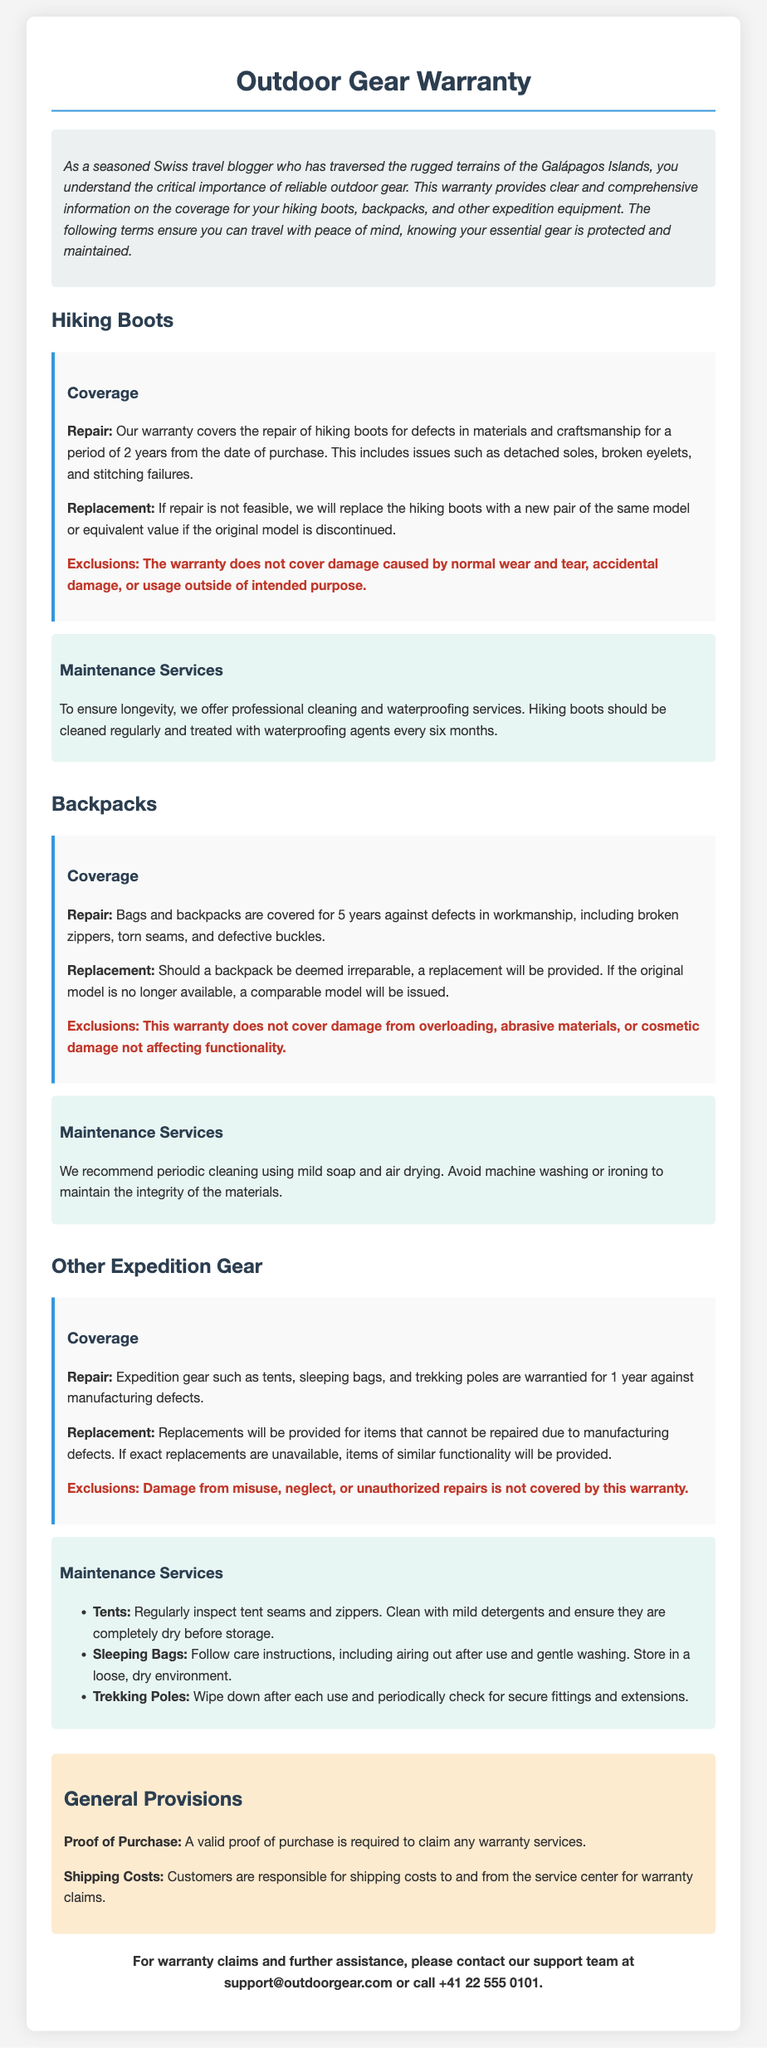What is the warranty period for hiking boots? The warranty period for hiking boots is 2 years from the date of purchase.
Answer: 2 years What types of damage are excluded from the hiking boots warranty? The exclusions for hiking boots include damage caused by normal wear and tear, accidental damage, or usage outside of intended purpose.
Answer: Normal wear and tear, accidental damage, usage outside of intended purpose What is the coverage duration for backpacks? The coverage duration for bags and backpacks is 5 years against defects in workmanship.
Answer: 5 years What maintenance service is recommended for hiking boots? The maintenance service recommended for hiking boots includes professional cleaning and waterproofing every six months.
Answer: Cleaning and waterproofing every six months How long is the warranty for other expedition gear? The warranty for expedition gear is 1 year against manufacturing defects.
Answer: 1 year What is required to claim any warranty services? A valid proof of purchase is required to claim any warranty services.
Answer: Proof of purchase What should be done to maintain trekking poles? To maintain trekking poles, one should wipe down after each use and periodically check for secure fittings and extensions.
Answer: Wipe down and check fittings What happens if a backpack cannot be repaired? If a backpack cannot be repaired, a replacement will be provided.
Answer: A replacement will be provided Who is responsible for shipping costs for warranty claims? Customers are responsible for shipping costs to and from the service center for warranty claims.
Answer: Customers 